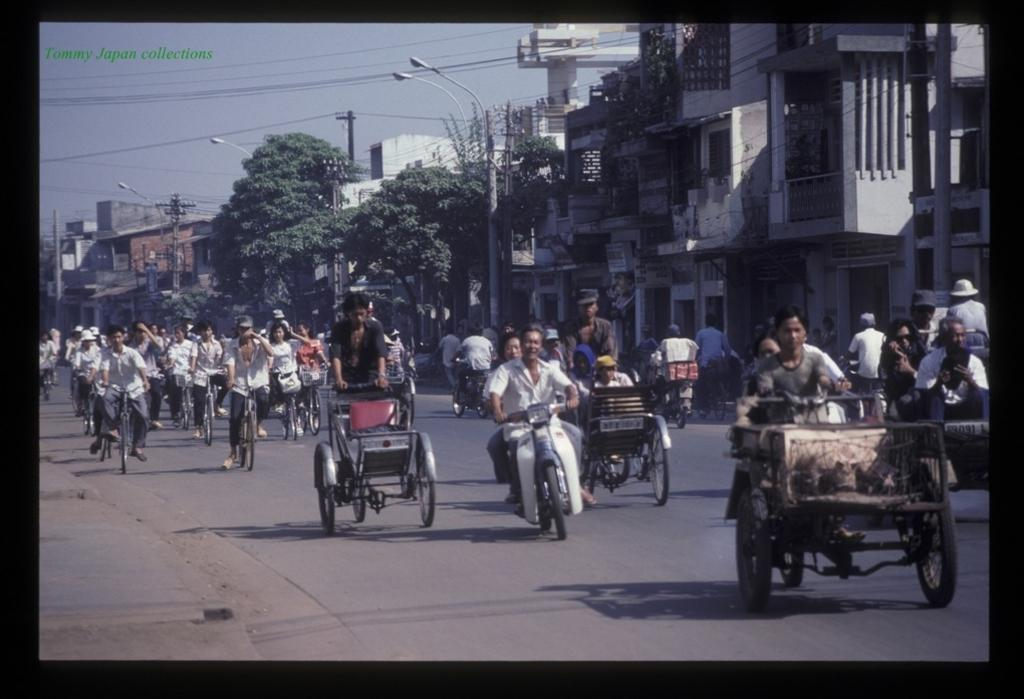What are the persons in the image doing? The persons in the image are riding bicycles. What can be seen in the center of the road in the image? There are vehicles in the center of the road in the image. What is visible in the background of the image? There are trees, buildings, poles, and wires in the background of the image. What type of corn is growing on the poles in the image? There is no corn visible in the image; the poles are supporting wires. What knowledge can be gained from the rabbit in the image? There is no rabbit present in the image, so no knowledge can be gained from it. 